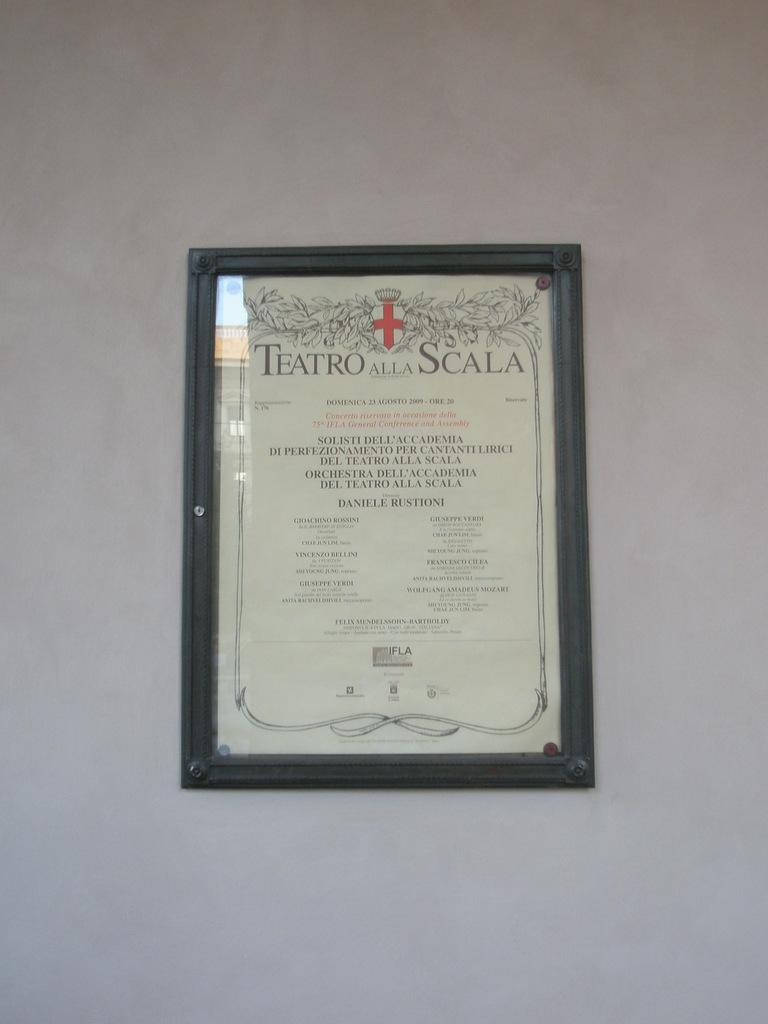<image>
Write a terse but informative summary of the picture. a picture with Teatro and Scala written at the top 